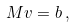<formula> <loc_0><loc_0><loc_500><loc_500>M v = b \, ,</formula> 